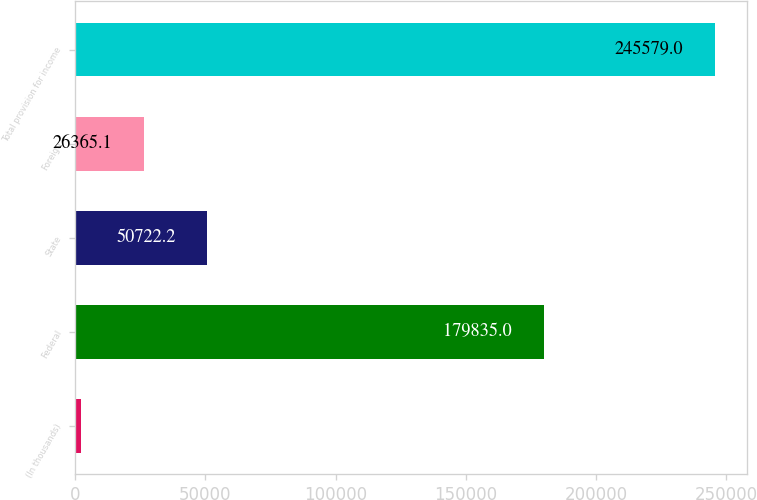Convert chart to OTSL. <chart><loc_0><loc_0><loc_500><loc_500><bar_chart><fcel>(In thousands)<fcel>Federal<fcel>State<fcel>Foreign<fcel>Total provision for income<nl><fcel>2008<fcel>179835<fcel>50722.2<fcel>26365.1<fcel>245579<nl></chart> 